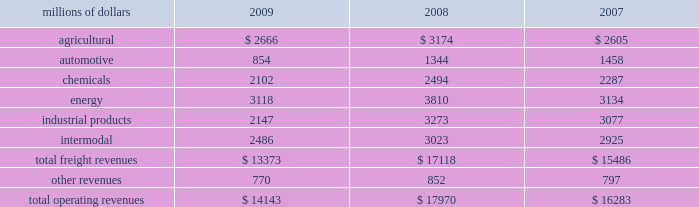Notes to the consolidated financial statements union pacific corporation and subsidiary companies for purposes of this report , unless the context otherwise requires , all references herein to the 201ccorporation 201d , 201cupc 201d , 201cwe 201d , 201cus 201d , and 201cour 201d mean union pacific corporation and its subsidiaries , including union pacific railroad company , which will be separately referred to herein as 201cuprr 201d or the 201crailroad 201d .
Nature of operations operations and segmentation 2013 we are a class i railroad that operates in the united states .
We have 32094 route miles , linking pacific coast and gulf coast ports with the midwest and eastern united states gateways and providing several corridors to key mexican gateways .
We serve the western two- thirds of the country and maintain coordinated schedules with other rail carriers for the handling of freight to and from the atlantic coast , the pacific coast , the southeast , the southwest , canada , and mexico .
Export and import traffic is moved through gulf coast and pacific coast ports and across the mexican and canadian borders .
The railroad , along with its subsidiaries and rail affiliates , is our one reportable operating segment .
Although revenues are analyzed by commodity group , we analyze the net financial results of the railroad as one segment due to the integrated nature of our rail network .
The table provides revenue by commodity group : millions of dollars 2009 2008 2007 .
Although our revenues are principally derived from customers domiciled in the united states , the ultimate points of origination or destination for some products transported are outside the united states .
Basis of presentation 2013 the consolidated financial statements are presented in accordance with accounting principles generally accepted in the united states of america ( gaap ) as codified in the financial accounting standards board ( fasb ) accounting standards codification ( asc ) .
Subsequent events evaluation 2013 we evaluated the effects of all subsequent events through february 5 , 2010 , the date of this report , which is concurrent with the date we file this report with the u.s .
Securities and exchange commission ( sec ) .
Significant accounting policies change in accounting principle 2013 we have historically accounted for rail grinding costs as a capital asset .
Beginning in the first quarter of 2010 , we will change our accounting policy for rail grinding costs .
What percent of total freight revenues was the chemicals group in 2008? 
Computations: (2494 / 17118)
Answer: 0.14569. 